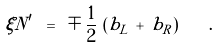Convert formula to latex. <formula><loc_0><loc_0><loc_500><loc_500>\xi N ^ { \prime } \ = \ \mp \, \frac { 1 } { 2 } \, \left ( b _ { L } \, + \, b _ { R } \right ) \quad .</formula> 